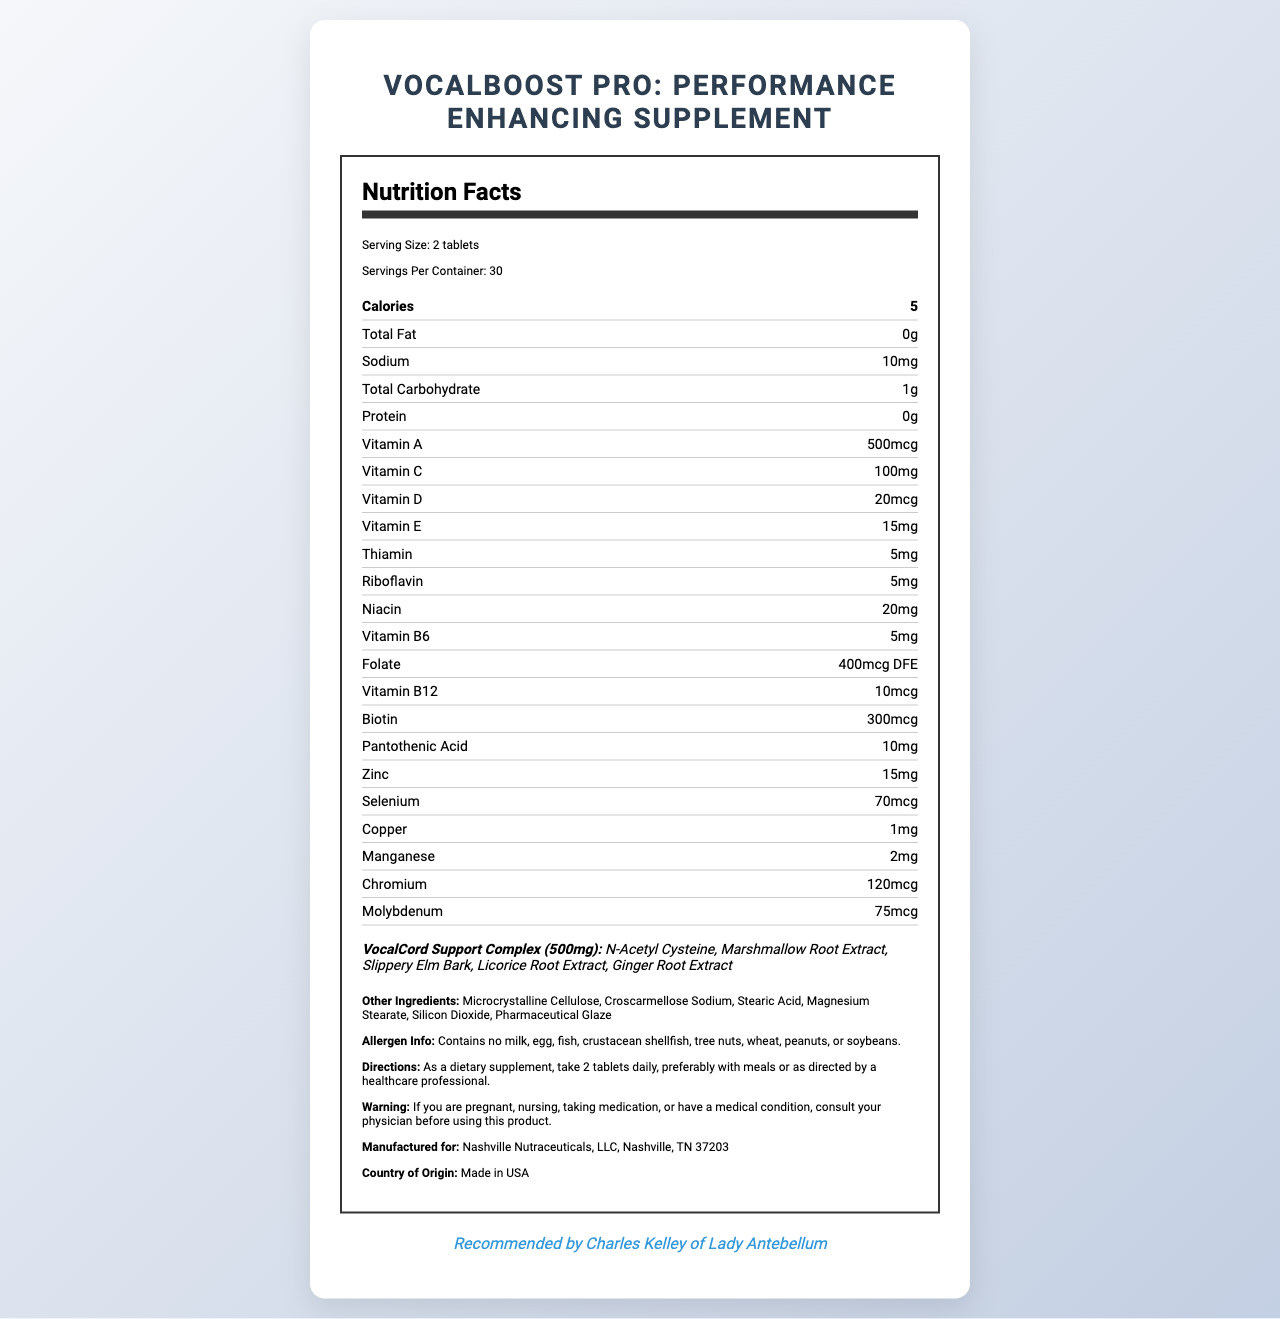what is the serving size? The document states that the serving size is 2 tablets.
Answer: 2 tablets how many servings are there per container? The document mentions that there are 30 servings per container.
Answer: 30 how many calories does each serving contain? Each serving contains 5 calories as indicated in the document.
Answer: 5 Does this supplement contain any protein? The document shows that the protein content is 0g indicating the absence of protein.
Answer: No how much vitamin C is in each serving? The document lists the vitamin C content as 100mg per serving.
Answer: 100mg What are the main ingredients of the proprietary blend? The document specifies these ingredients under the "VocalCord Support Complex."
Answer: N-Acetyl Cysteine, Marshmallow Root Extract, Slippery Elm Bark, Licorice Root Extract, Ginger Root Extract is there any sodium in this supplement? The document mentions that there is 10mg of sodium per serving.
Answer: Yes What is the name of the supplement product? The top of the document states the product name clearly.
Answer: VocalBoost Pro: Performance Enhancing Supplement which vitamin has the highest amount per serving? A. Vitamin A B. Vitamin C C. Vitamin D Vitamin C has the highest amount per serving at 100mg compared to Vitamin A (500mcg) and Vitamin D (20mcg).
Answer: B how many micrograms of biotin are present in each serving? The document details that each serving contains 300mcg of biotin.
Answer: 300mcg which of the following minerals are included in the supplement? A. Calcium B. Iron C. Zinc The document lists zinc with an amount of 15mg, but calcium and iron are not mentioned.
Answer: C Is the supplement recommended by a member of Lady Antebellum? The document states that the supplement is recommended by Charles Kelley of Lady Antebellum.
Answer: Yes Does the supplement contain any allergens like milk or peanuts? The document specifically states that it contains no milk, egg, fish, crustacean shellfish, tree nuts, wheat, peanuts, or soybeans.
Answer: No describe the primary purpose and components of the document This summary covers the various sections listed in the document including the supplement's properties, composition, and usage recommendations.
Answer: The document is a Nutrition Facts Label for VocalBoost Pro: Performance Enhancing Supplement, detailing its serving size, nutritional content, proprietary blend ingredients, other ingredients, allergen information, directions for use, warnings, and endorsements. what is the manufacturer's name? The document states that the supplement is manufactured for Nashville Nutraceuticals, LLC, Nashville, TN 37203.
Answer: Nashville Nutraceuticals, LLC Can the supplement replace a meal? The document does not provide information about whether this supplement can replace a meal or not.
Answer: Not enough information 